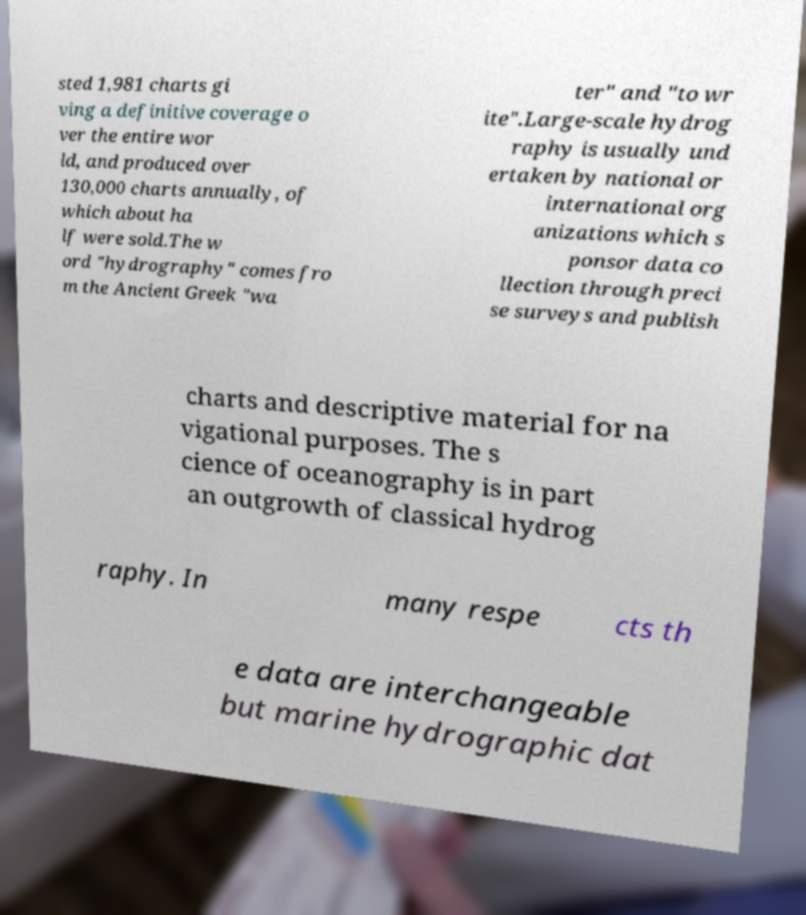Can you read and provide the text displayed in the image?This photo seems to have some interesting text. Can you extract and type it out for me? sted 1,981 charts gi ving a definitive coverage o ver the entire wor ld, and produced over 130,000 charts annually, of which about ha lf were sold.The w ord "hydrography" comes fro m the Ancient Greek "wa ter" and "to wr ite".Large-scale hydrog raphy is usually und ertaken by national or international org anizations which s ponsor data co llection through preci se surveys and publish charts and descriptive material for na vigational purposes. The s cience of oceanography is in part an outgrowth of classical hydrog raphy. In many respe cts th e data are interchangeable but marine hydrographic dat 